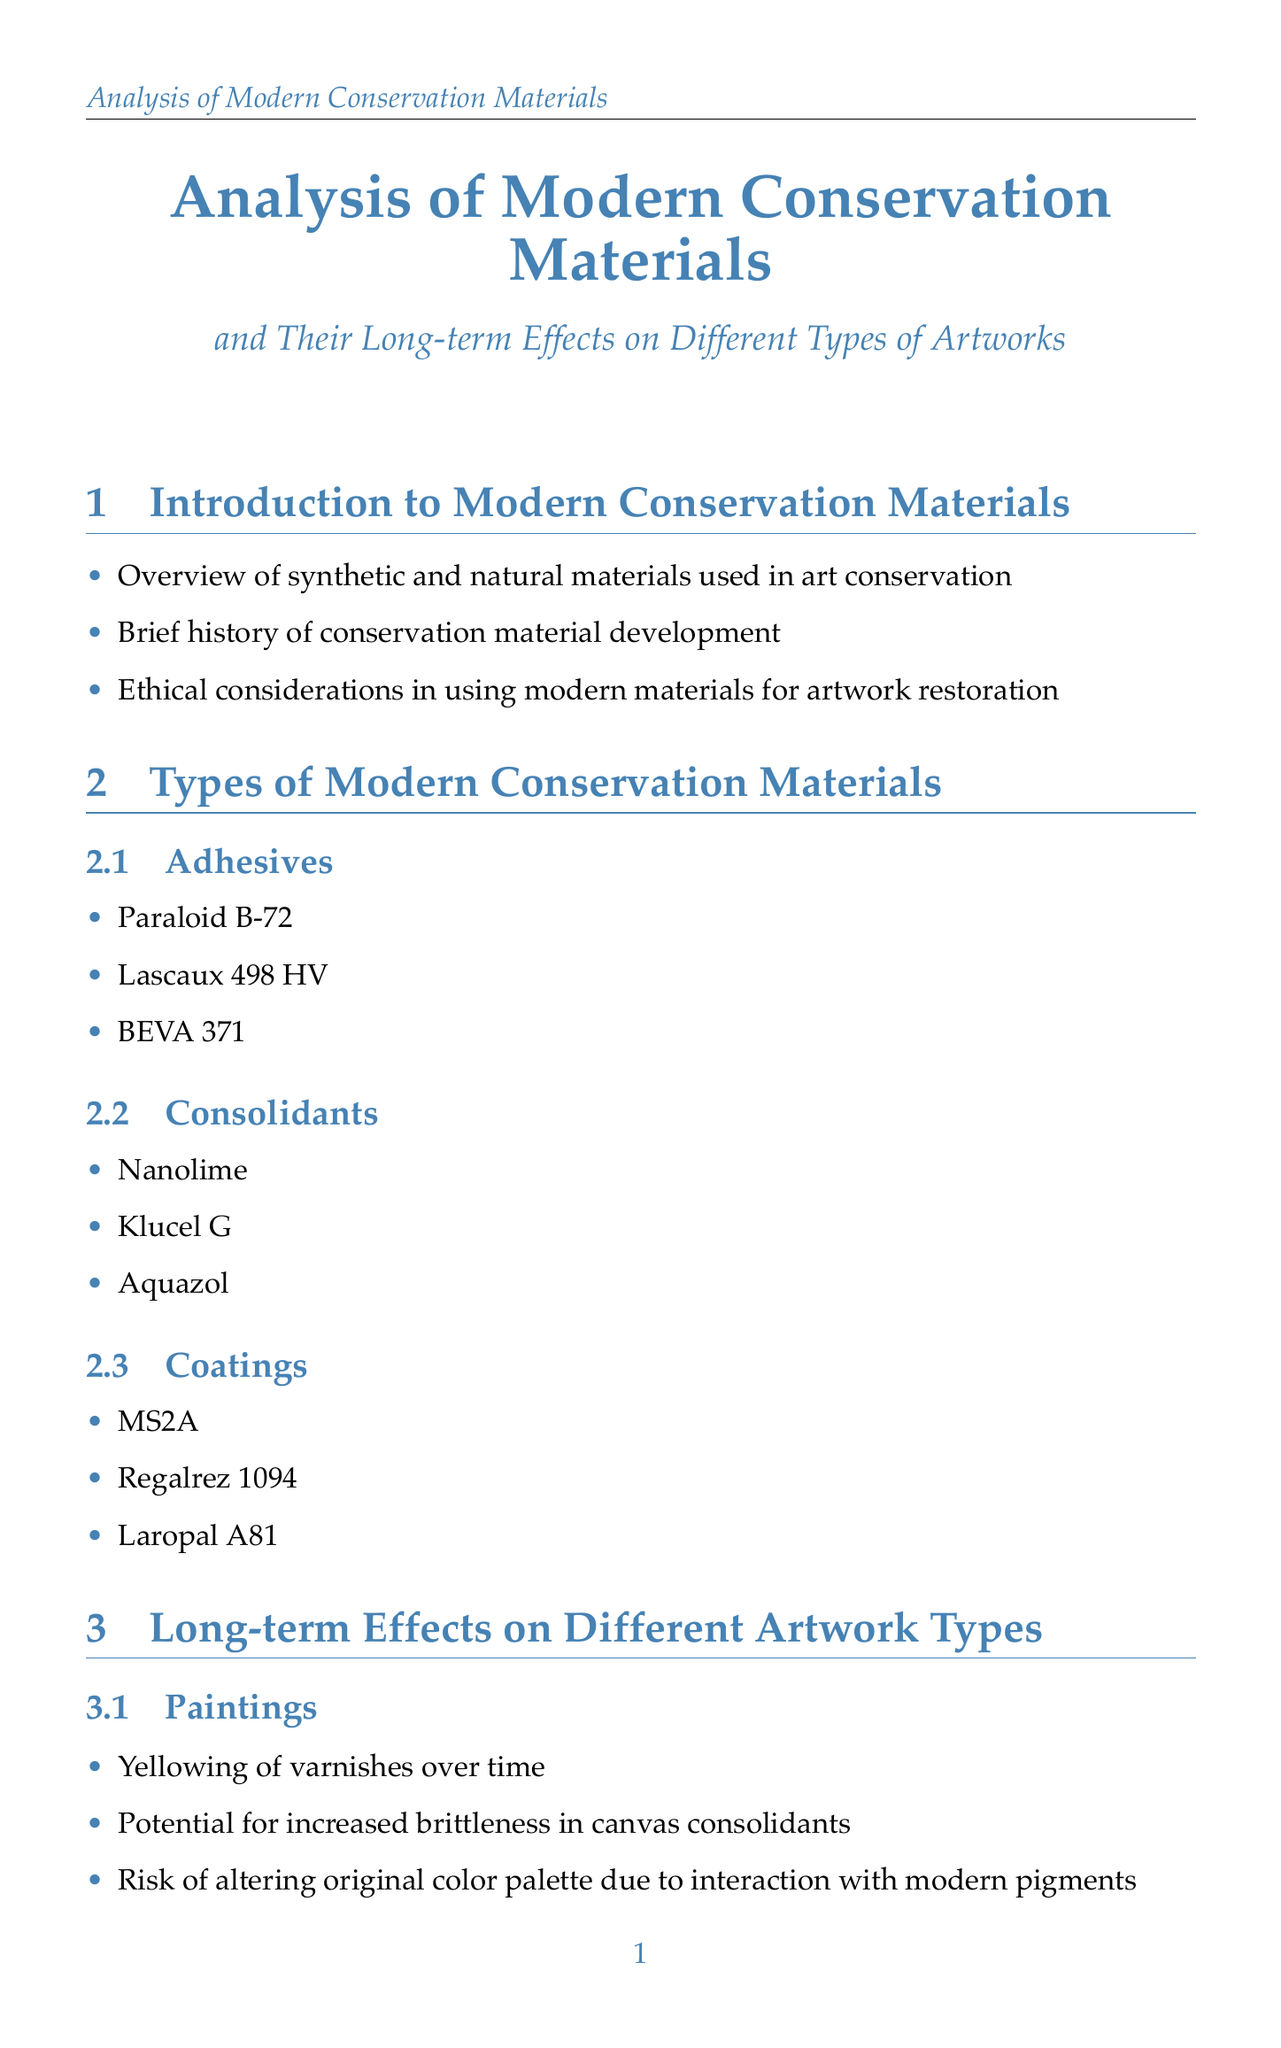What are the three categories of modern conservation materials? The document lists Adhesives, Consolidants, and Coatings as the three categories of modern conservation materials.
Answer: Adhesives, Consolidants, Coatings Which analytical technique is used for elemental analysis? The document states that X-ray Fluorescence (XRF) spectroscopy is used for elemental analysis.
Answer: X-ray Fluorescence (XRF) What is a potential consequence of using modern coatings on sculptures? The document indicates that one consequence is an altered surface appearance due to modern coatings on sculptures.
Answer: Altered surface appearance What was the issue with the restoration of Ecce Homo in Borja, Spain? The document mentions that the issue was an amateur restoration attempt using modern materials.
Answer: Amateur restoration attempt What ethical guideline organization is mentioned in relation to conservation? The document refers to ICOM-CC as an organization providing ethical guidelines in conservation.
Answer: ICOM-CC What is a long-term effect of consolidants on paintings? The document lists the potential for increased brittleness in canvas consolidants as a long-term effect.
Answer: Increased brittleness What type of materials are suggested for future conservation developments? The document suggests the development of bio-based and sustainable conservation materials as a future direction.
Answer: Bio-based and sustainable Which artwork experienced darkening due to varnish application in the 1970s? The document states that "The Night Watch by Rembrandt" experienced darkening due to varnish application in the 1970s.
Answer: The Night Watch by Rembrandt 